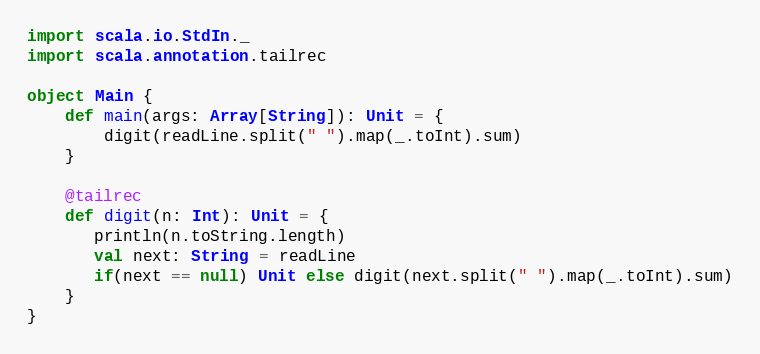<code> <loc_0><loc_0><loc_500><loc_500><_Scala_>import scala.io.StdIn._
import scala.annotation.tailrec

object Main {
    def main(args: Array[String]): Unit = { 
        digit(readLine.split(" ").map(_.toInt).sum)
    }
    
    @tailrec
    def digit(n: Int): Unit = {
       println(n.toString.length)
       val next: String = readLine
       if(next == null) Unit else digit(next.split(" ").map(_.toInt).sum)
    }
}</code> 